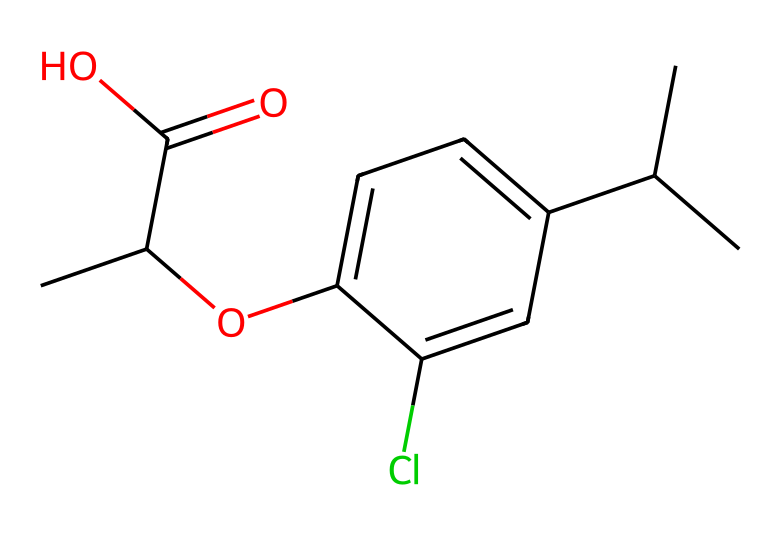What is the molecular formula of mecoprop? To determine the molecular formula, count the number of each type of atom in the SMILES representation. The segments CC(C(=O)O) indicate carbon (C), and O indicates oxygen. Counting gives: C=12, H=15, O=3, Cl=1. Thus, the molecular formula is C12H15ClO3.
Answer: C12H15ClO3 How many carbon atoms are in the chemical structure of mecoprop? By analyzing the SMILES, we can see there are 12 "C" letters representing carbon atoms. This is verified by counting the "C" in the representation, indicating there are no missing or implied carbon atoms.
Answer: 12 What functional groups are present in mecoprop? Looking at the structure, the presence of a carboxylic acid (C(=O)O) and an ether (C-O-C) can be identified. The chlorine substituent (Cl) is also noteworthy as it impacts the chemical properties.
Answer: carboxylic acid, ether, chlorine Is mecoprop likely to be polar or nonpolar? Considering the presence of the carboxylic acid and ether functional groups, which can invoke dipole interactions, mecoprop is likely polar. The chlorine atom also contributes to this effect.
Answer: polar How does the chlorine atom affect the herbicidal activity of mecoprop? The presence of the chlorine atom in the structure can enhance herbicidal activity by affecting the molecule's lipid solubility and reactivity, thus impacting how it interacts with plant target sites. This is a reasoning-based observation combining knowledge of herbicide functions.
Answer: enhances activity What type of herbicide is mecoprop classified as? Mecoprop is classified as a selective herbicide because it affects specific types of plants while leaving others unharmed. This is determined by its chemical structure which targets certain biological pathways.
Answer: selective 